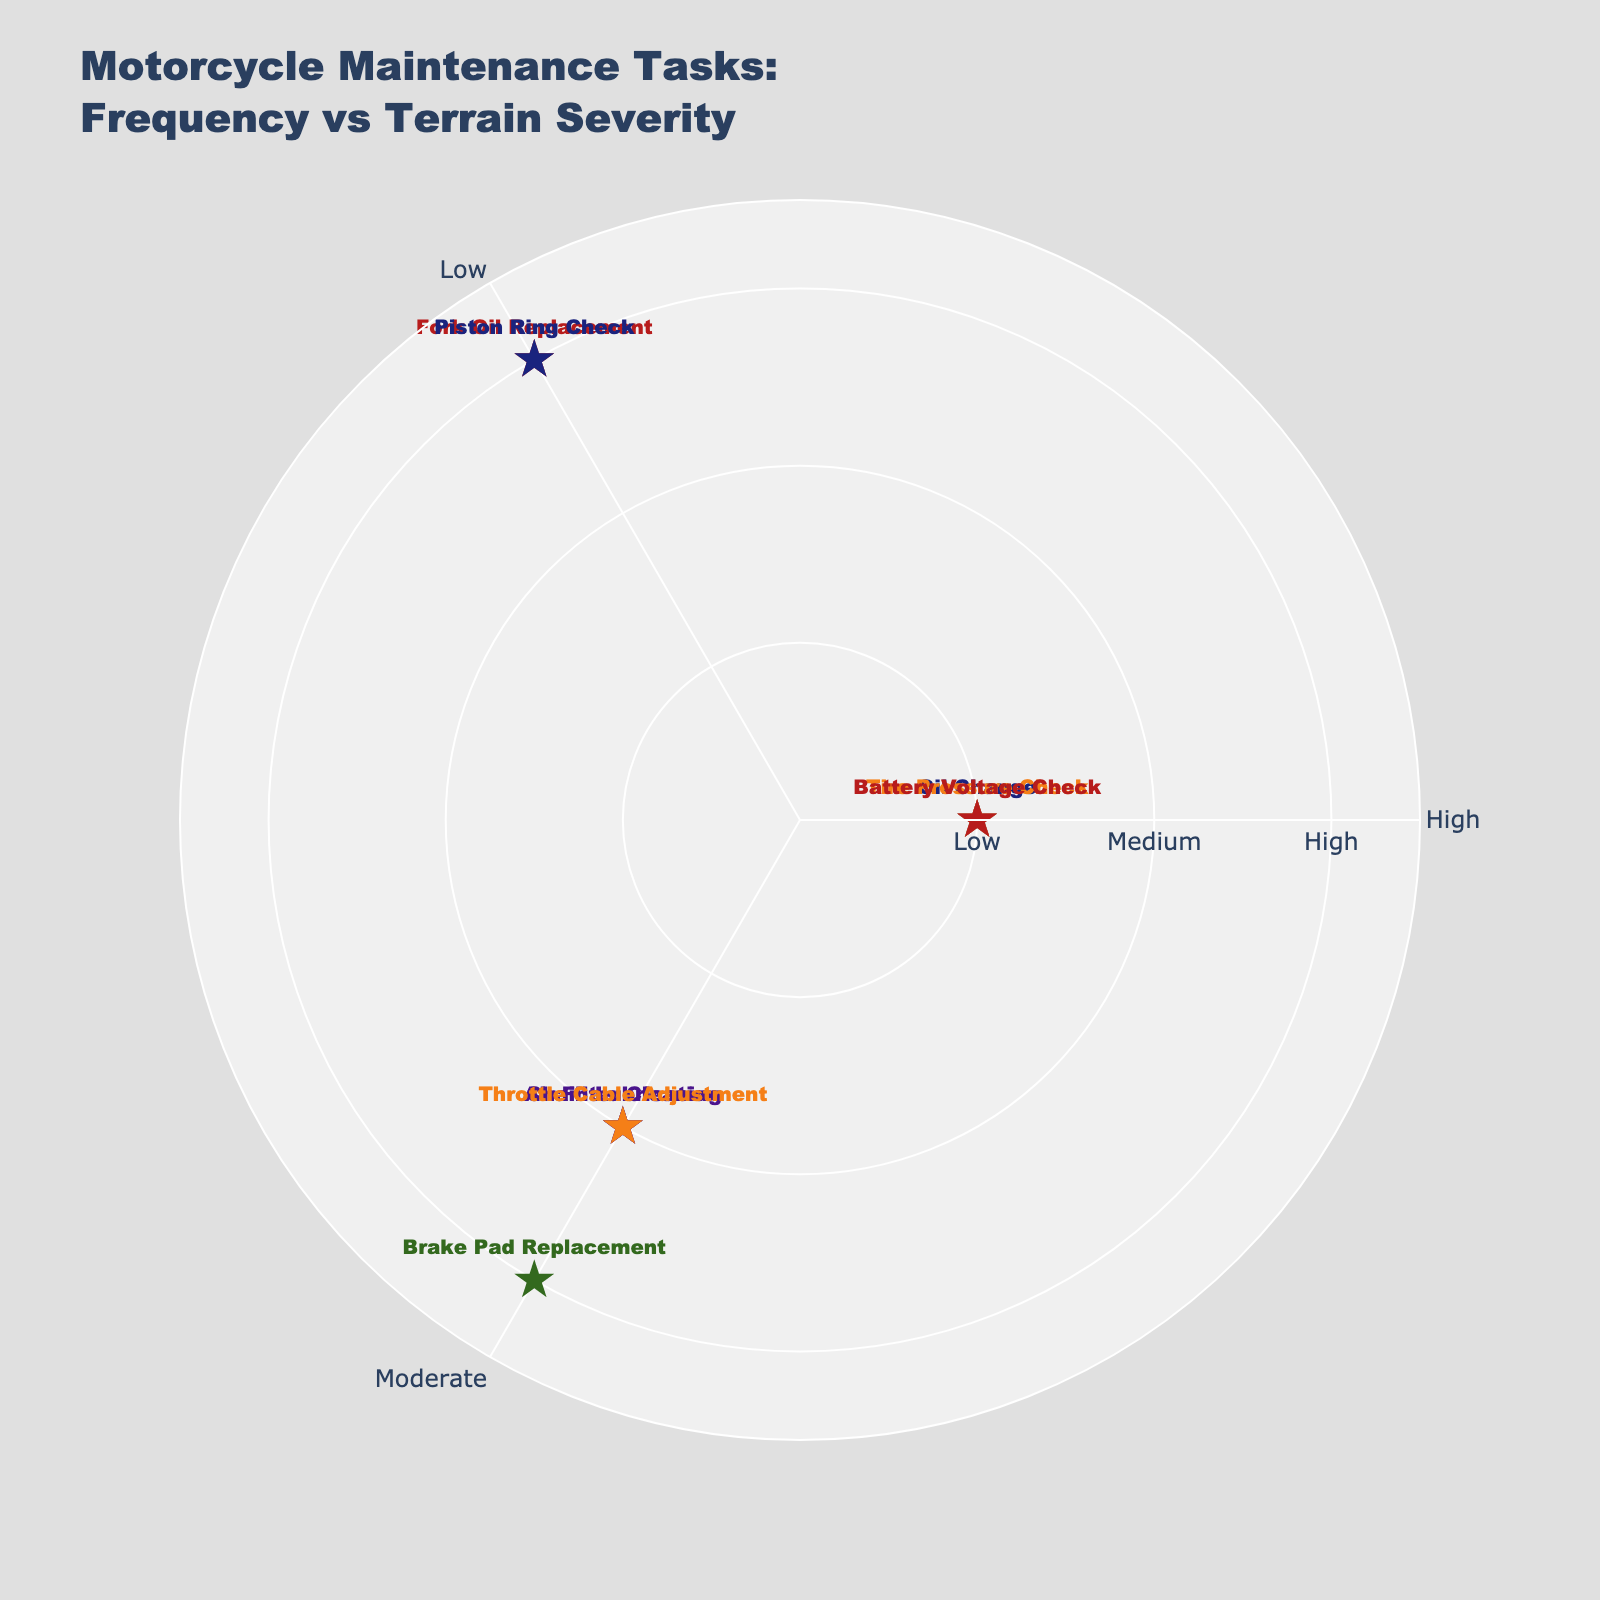What's the title of the polar scatter chart? The title of the chart is clearly stated above the plot area. It reads 'Motorcycle Maintenance Tasks: Frequency vs Terrain Severity'.
Answer: 'Motorcycle Maintenance Tasks: Frequency vs Terrain Severity' How many tasks need to be performed for terrains with high severity? By observing the radial axis of the chart, you can count the data points located at the outermost circle (high severity). These tasks are 'Fork Oil Replacement', 'Brake Pad Replacement', and 'Piston Ring Check'.
Answer: 3 Which task has the highest frequency and lowest terrain severity? The angular axis can be used to identify tasks with the highest frequency (120°) and the radial distance tells us they are at the lowest terrain severity (closest to the center). The relevant tasks are 'Oil Change', 'Tire Pressure Check', and 'Battery Voltage Check'.
Answer: 'Oil Change', 'Tire Pressure Check', 'Battery Voltage Check' What's the primary part involved in tasks with moderate frequency and medium terrain severity? Locate tasks plotted at an angle of 240° (moderate frequency) and at the middle circle (medium severity). The tasks are 'Chain Lubrication', 'Air Filter Cleaning', and 'Throttle Cable Adjustment'. The parts involved are the chain, air filter, and cables.
Answer: Chain, air filter, cables How many tasks have a moderate frequency but vary in terrain severity? Tasks plotted at an angle of 240° (moderate frequency) can be counted from the center to the outer circle. They are 'Chain Lubrication' (Medium), 'Brake Pad Replacement' (High), 'Air Filter Cleaning' (Medium), and 'Throttle Cable Adjustment' (Medium).
Answer: 4 What is the relationship between the severity of terrains and the frequency of maintenance tasks? By observing the plot, we can infer that tasks required for high severity terrains tend to have low or moderate frequency, while tasks for low terrain severity have higher frequency.
Answer: High severity terrains have lower frequency tasks; low severity terrains have higher frequency tasks Which tasks are more frequently performed compared to brake pad replacement? Locate 'Brake Pad Replacement' which lies at 240° (moderate frequency) and at the outermost circle (high severity); then look for tasks closer to 120° (high frequency) and compare distances. These are 'Oil Change', 'Tire Pressure Check', and 'Battery Voltage Check'.
Answer: 'Oil Change', 'Tire Pressure Check', and 'Battery Voltage Check' Is there any task that sits exactly on the boundary between low and moderate frequency? Tasks that have an angle of either 120° or 240° and are exactly in between. None of the tasks fall exactly between these angles.
Answer: No Which maintenance task appears on the plot but is the least frequent? The radial distance is closest to the center indicating low frequency. 'Fork Oil Replacement' and 'Piston Ring Check' are plotted closest to the center.
Answer: 'Fork Oil Replacement', 'Piston Ring Check' 